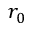Convert formula to latex. <formula><loc_0><loc_0><loc_500><loc_500>r _ { 0 }</formula> 